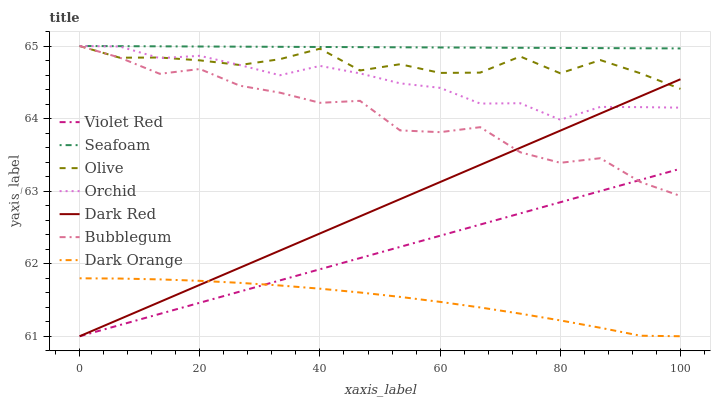Does Dark Orange have the minimum area under the curve?
Answer yes or no. Yes. Does Seafoam have the maximum area under the curve?
Answer yes or no. Yes. Does Violet Red have the minimum area under the curve?
Answer yes or no. No. Does Violet Red have the maximum area under the curve?
Answer yes or no. No. Is Violet Red the smoothest?
Answer yes or no. Yes. Is Bubblegum the roughest?
Answer yes or no. Yes. Is Dark Red the smoothest?
Answer yes or no. No. Is Dark Red the roughest?
Answer yes or no. No. Does Dark Orange have the lowest value?
Answer yes or no. Yes. Does Seafoam have the lowest value?
Answer yes or no. No. Does Orchid have the highest value?
Answer yes or no. Yes. Does Violet Red have the highest value?
Answer yes or no. No. Is Violet Red less than Orchid?
Answer yes or no. Yes. Is Orchid greater than Dark Orange?
Answer yes or no. Yes. Does Olive intersect Orchid?
Answer yes or no. Yes. Is Olive less than Orchid?
Answer yes or no. No. Is Olive greater than Orchid?
Answer yes or no. No. Does Violet Red intersect Orchid?
Answer yes or no. No. 